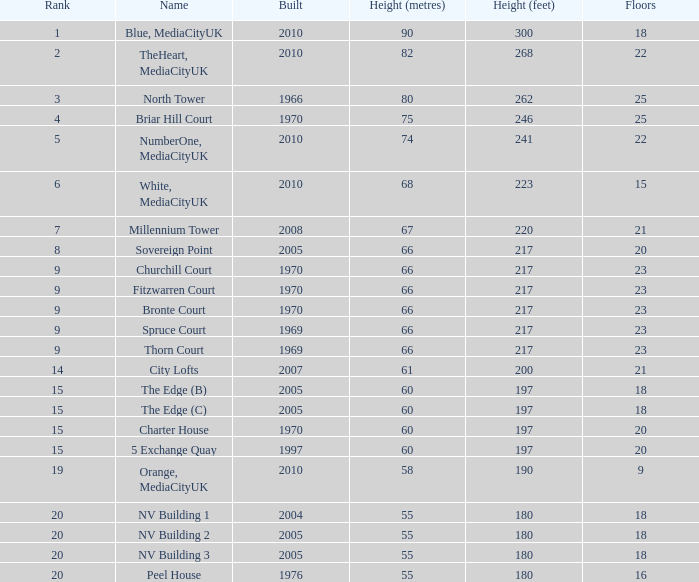What is the lowest Built, when Floors is greater than 23, and when Rank is 3? 1966.0. 